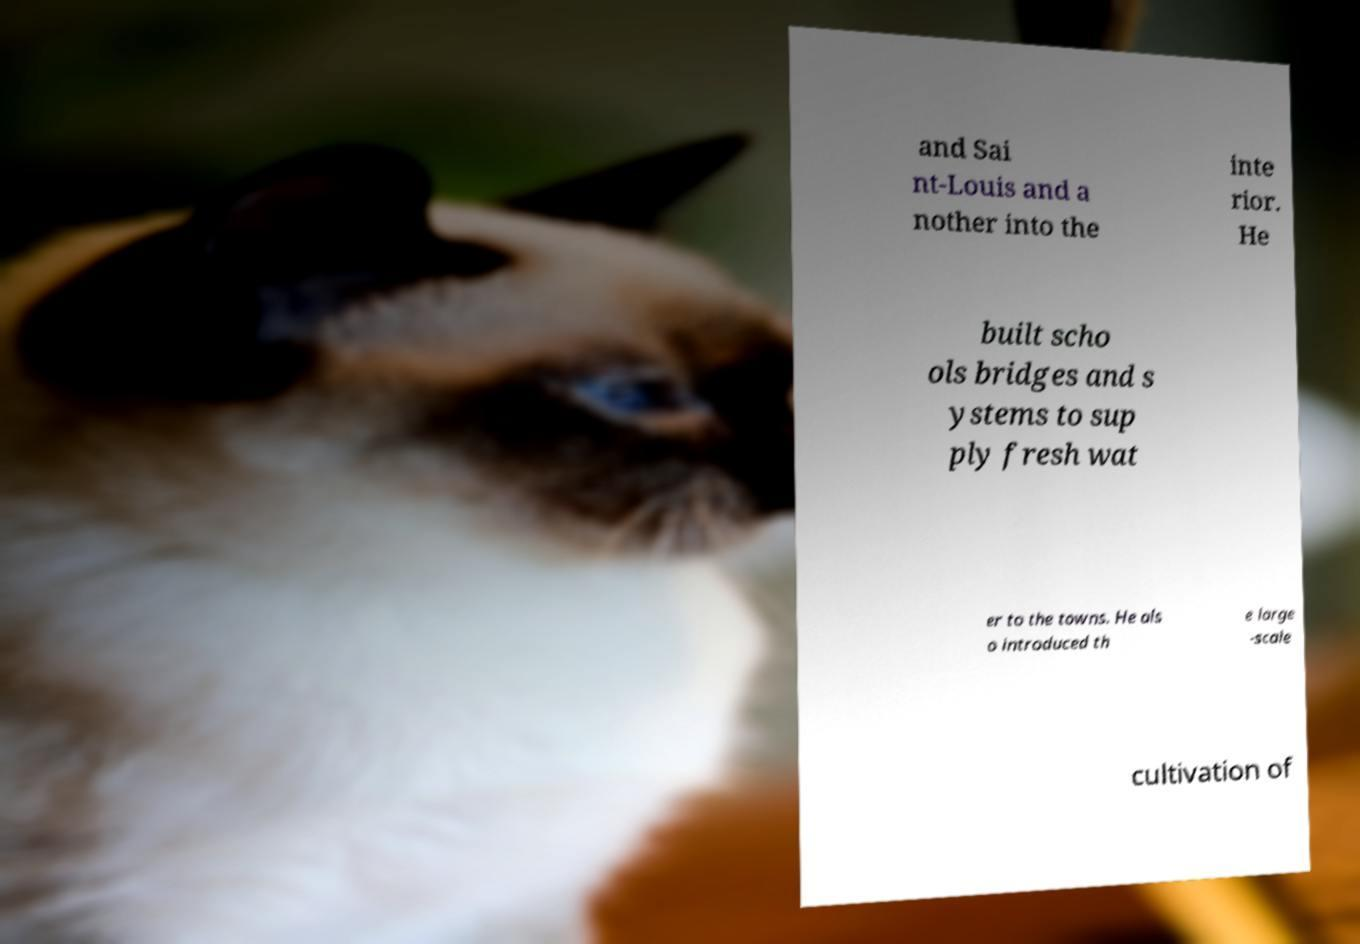There's text embedded in this image that I need extracted. Can you transcribe it verbatim? and Sai nt-Louis and a nother into the inte rior. He built scho ols bridges and s ystems to sup ply fresh wat er to the towns. He als o introduced th e large -scale cultivation of 